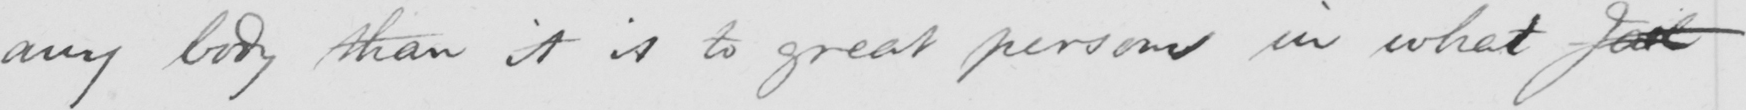Please provide the text content of this handwritten line. any body than it is to great persons in what Jal 